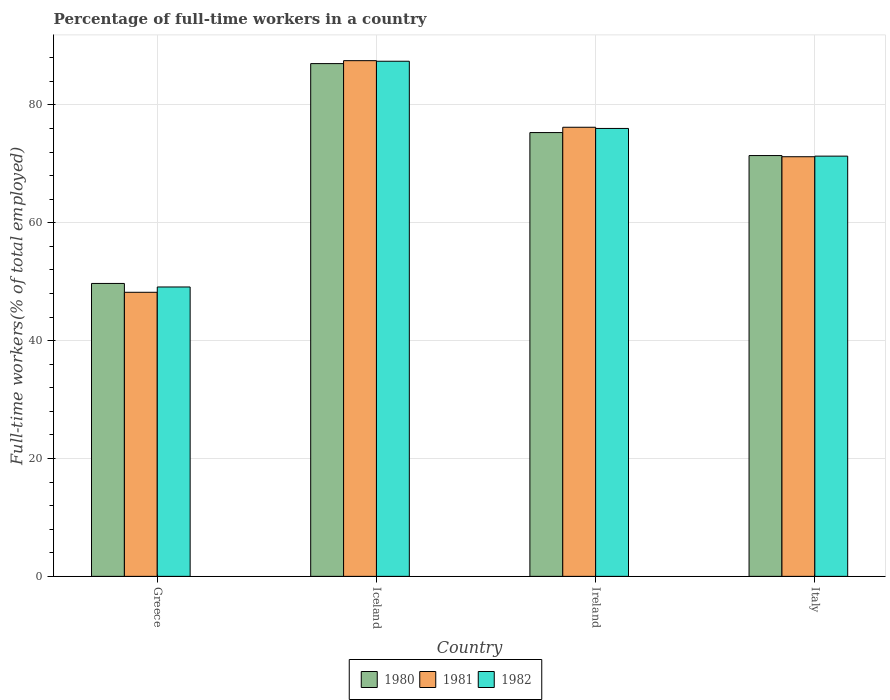Are the number of bars per tick equal to the number of legend labels?
Offer a very short reply. Yes. How many bars are there on the 1st tick from the left?
Keep it short and to the point. 3. How many bars are there on the 4th tick from the right?
Your answer should be compact. 3. What is the percentage of full-time workers in 1981 in Greece?
Make the answer very short. 48.2. Across all countries, what is the maximum percentage of full-time workers in 1981?
Make the answer very short. 87.5. Across all countries, what is the minimum percentage of full-time workers in 1981?
Your response must be concise. 48.2. In which country was the percentage of full-time workers in 1982 maximum?
Your answer should be very brief. Iceland. What is the total percentage of full-time workers in 1981 in the graph?
Your response must be concise. 283.1. What is the difference between the percentage of full-time workers in 1982 in Greece and that in Ireland?
Ensure brevity in your answer.  -26.9. What is the difference between the percentage of full-time workers in 1981 in Ireland and the percentage of full-time workers in 1982 in Iceland?
Give a very brief answer. -11.2. What is the average percentage of full-time workers in 1980 per country?
Keep it short and to the point. 70.85. What is the difference between the percentage of full-time workers of/in 1982 and percentage of full-time workers of/in 1981 in Iceland?
Ensure brevity in your answer.  -0.1. In how many countries, is the percentage of full-time workers in 1982 greater than 36 %?
Provide a short and direct response. 4. What is the ratio of the percentage of full-time workers in 1981 in Ireland to that in Italy?
Keep it short and to the point. 1.07. Is the percentage of full-time workers in 1980 in Greece less than that in Iceland?
Your response must be concise. Yes. Is the difference between the percentage of full-time workers in 1982 in Greece and Iceland greater than the difference between the percentage of full-time workers in 1981 in Greece and Iceland?
Provide a short and direct response. Yes. What is the difference between the highest and the second highest percentage of full-time workers in 1980?
Give a very brief answer. 3.9. What is the difference between the highest and the lowest percentage of full-time workers in 1980?
Your response must be concise. 37.3. Is the sum of the percentage of full-time workers in 1981 in Greece and Italy greater than the maximum percentage of full-time workers in 1980 across all countries?
Offer a terse response. Yes. Is it the case that in every country, the sum of the percentage of full-time workers in 1980 and percentage of full-time workers in 1981 is greater than the percentage of full-time workers in 1982?
Give a very brief answer. Yes. Are all the bars in the graph horizontal?
Your answer should be very brief. No. Does the graph contain any zero values?
Your answer should be very brief. No. Where does the legend appear in the graph?
Provide a succinct answer. Bottom center. How are the legend labels stacked?
Provide a succinct answer. Horizontal. What is the title of the graph?
Offer a very short reply. Percentage of full-time workers in a country. What is the label or title of the X-axis?
Ensure brevity in your answer.  Country. What is the label or title of the Y-axis?
Ensure brevity in your answer.  Full-time workers(% of total employed). What is the Full-time workers(% of total employed) in 1980 in Greece?
Give a very brief answer. 49.7. What is the Full-time workers(% of total employed) of 1981 in Greece?
Your answer should be compact. 48.2. What is the Full-time workers(% of total employed) of 1982 in Greece?
Give a very brief answer. 49.1. What is the Full-time workers(% of total employed) in 1981 in Iceland?
Provide a short and direct response. 87.5. What is the Full-time workers(% of total employed) in 1982 in Iceland?
Offer a terse response. 87.4. What is the Full-time workers(% of total employed) of 1980 in Ireland?
Your answer should be very brief. 75.3. What is the Full-time workers(% of total employed) in 1981 in Ireland?
Make the answer very short. 76.2. What is the Full-time workers(% of total employed) of 1982 in Ireland?
Ensure brevity in your answer.  76. What is the Full-time workers(% of total employed) in 1980 in Italy?
Provide a succinct answer. 71.4. What is the Full-time workers(% of total employed) of 1981 in Italy?
Your answer should be compact. 71.2. What is the Full-time workers(% of total employed) of 1982 in Italy?
Keep it short and to the point. 71.3. Across all countries, what is the maximum Full-time workers(% of total employed) of 1980?
Keep it short and to the point. 87. Across all countries, what is the maximum Full-time workers(% of total employed) of 1981?
Offer a terse response. 87.5. Across all countries, what is the maximum Full-time workers(% of total employed) in 1982?
Keep it short and to the point. 87.4. Across all countries, what is the minimum Full-time workers(% of total employed) in 1980?
Give a very brief answer. 49.7. Across all countries, what is the minimum Full-time workers(% of total employed) of 1981?
Ensure brevity in your answer.  48.2. Across all countries, what is the minimum Full-time workers(% of total employed) in 1982?
Keep it short and to the point. 49.1. What is the total Full-time workers(% of total employed) of 1980 in the graph?
Offer a very short reply. 283.4. What is the total Full-time workers(% of total employed) of 1981 in the graph?
Provide a short and direct response. 283.1. What is the total Full-time workers(% of total employed) of 1982 in the graph?
Give a very brief answer. 283.8. What is the difference between the Full-time workers(% of total employed) of 1980 in Greece and that in Iceland?
Offer a very short reply. -37.3. What is the difference between the Full-time workers(% of total employed) of 1981 in Greece and that in Iceland?
Your answer should be compact. -39.3. What is the difference between the Full-time workers(% of total employed) in 1982 in Greece and that in Iceland?
Offer a very short reply. -38.3. What is the difference between the Full-time workers(% of total employed) in 1980 in Greece and that in Ireland?
Make the answer very short. -25.6. What is the difference between the Full-time workers(% of total employed) in 1981 in Greece and that in Ireland?
Your response must be concise. -28. What is the difference between the Full-time workers(% of total employed) in 1982 in Greece and that in Ireland?
Your response must be concise. -26.9. What is the difference between the Full-time workers(% of total employed) of 1980 in Greece and that in Italy?
Your answer should be very brief. -21.7. What is the difference between the Full-time workers(% of total employed) in 1982 in Greece and that in Italy?
Offer a terse response. -22.2. What is the difference between the Full-time workers(% of total employed) in 1980 in Iceland and that in Ireland?
Provide a short and direct response. 11.7. What is the difference between the Full-time workers(% of total employed) of 1980 in Iceland and that in Italy?
Ensure brevity in your answer.  15.6. What is the difference between the Full-time workers(% of total employed) in 1981 in Iceland and that in Italy?
Ensure brevity in your answer.  16.3. What is the difference between the Full-time workers(% of total employed) of 1982 in Iceland and that in Italy?
Provide a succinct answer. 16.1. What is the difference between the Full-time workers(% of total employed) of 1980 in Ireland and that in Italy?
Your response must be concise. 3.9. What is the difference between the Full-time workers(% of total employed) in 1981 in Ireland and that in Italy?
Offer a terse response. 5. What is the difference between the Full-time workers(% of total employed) of 1982 in Ireland and that in Italy?
Offer a very short reply. 4.7. What is the difference between the Full-time workers(% of total employed) in 1980 in Greece and the Full-time workers(% of total employed) in 1981 in Iceland?
Your answer should be very brief. -37.8. What is the difference between the Full-time workers(% of total employed) of 1980 in Greece and the Full-time workers(% of total employed) of 1982 in Iceland?
Your answer should be compact. -37.7. What is the difference between the Full-time workers(% of total employed) of 1981 in Greece and the Full-time workers(% of total employed) of 1982 in Iceland?
Make the answer very short. -39.2. What is the difference between the Full-time workers(% of total employed) in 1980 in Greece and the Full-time workers(% of total employed) in 1981 in Ireland?
Your answer should be compact. -26.5. What is the difference between the Full-time workers(% of total employed) in 1980 in Greece and the Full-time workers(% of total employed) in 1982 in Ireland?
Give a very brief answer. -26.3. What is the difference between the Full-time workers(% of total employed) of 1981 in Greece and the Full-time workers(% of total employed) of 1982 in Ireland?
Provide a short and direct response. -27.8. What is the difference between the Full-time workers(% of total employed) in 1980 in Greece and the Full-time workers(% of total employed) in 1981 in Italy?
Your response must be concise. -21.5. What is the difference between the Full-time workers(% of total employed) of 1980 in Greece and the Full-time workers(% of total employed) of 1982 in Italy?
Offer a very short reply. -21.6. What is the difference between the Full-time workers(% of total employed) of 1981 in Greece and the Full-time workers(% of total employed) of 1982 in Italy?
Your answer should be very brief. -23.1. What is the difference between the Full-time workers(% of total employed) in 1981 in Iceland and the Full-time workers(% of total employed) in 1982 in Ireland?
Give a very brief answer. 11.5. What is the difference between the Full-time workers(% of total employed) of 1980 in Iceland and the Full-time workers(% of total employed) of 1981 in Italy?
Provide a short and direct response. 15.8. What is the difference between the Full-time workers(% of total employed) in 1980 in Iceland and the Full-time workers(% of total employed) in 1982 in Italy?
Provide a short and direct response. 15.7. What is the difference between the Full-time workers(% of total employed) in 1980 in Ireland and the Full-time workers(% of total employed) in 1982 in Italy?
Make the answer very short. 4. What is the difference between the Full-time workers(% of total employed) of 1981 in Ireland and the Full-time workers(% of total employed) of 1982 in Italy?
Keep it short and to the point. 4.9. What is the average Full-time workers(% of total employed) of 1980 per country?
Make the answer very short. 70.85. What is the average Full-time workers(% of total employed) in 1981 per country?
Make the answer very short. 70.78. What is the average Full-time workers(% of total employed) of 1982 per country?
Offer a very short reply. 70.95. What is the difference between the Full-time workers(% of total employed) in 1980 and Full-time workers(% of total employed) in 1981 in Greece?
Provide a succinct answer. 1.5. What is the difference between the Full-time workers(% of total employed) of 1980 and Full-time workers(% of total employed) of 1982 in Greece?
Offer a terse response. 0.6. What is the difference between the Full-time workers(% of total employed) in 1980 and Full-time workers(% of total employed) in 1981 in Iceland?
Provide a succinct answer. -0.5. What is the difference between the Full-time workers(% of total employed) in 1980 and Full-time workers(% of total employed) in 1982 in Iceland?
Keep it short and to the point. -0.4. What is the difference between the Full-time workers(% of total employed) in 1981 and Full-time workers(% of total employed) in 1982 in Iceland?
Make the answer very short. 0.1. What is the difference between the Full-time workers(% of total employed) of 1980 and Full-time workers(% of total employed) of 1982 in Ireland?
Provide a short and direct response. -0.7. What is the difference between the Full-time workers(% of total employed) of 1981 and Full-time workers(% of total employed) of 1982 in Ireland?
Your answer should be compact. 0.2. What is the difference between the Full-time workers(% of total employed) of 1980 and Full-time workers(% of total employed) of 1981 in Italy?
Offer a terse response. 0.2. What is the difference between the Full-time workers(% of total employed) of 1980 and Full-time workers(% of total employed) of 1982 in Italy?
Provide a succinct answer. 0.1. What is the ratio of the Full-time workers(% of total employed) of 1980 in Greece to that in Iceland?
Offer a terse response. 0.57. What is the ratio of the Full-time workers(% of total employed) in 1981 in Greece to that in Iceland?
Your answer should be compact. 0.55. What is the ratio of the Full-time workers(% of total employed) in 1982 in Greece to that in Iceland?
Make the answer very short. 0.56. What is the ratio of the Full-time workers(% of total employed) of 1980 in Greece to that in Ireland?
Give a very brief answer. 0.66. What is the ratio of the Full-time workers(% of total employed) of 1981 in Greece to that in Ireland?
Offer a terse response. 0.63. What is the ratio of the Full-time workers(% of total employed) in 1982 in Greece to that in Ireland?
Provide a short and direct response. 0.65. What is the ratio of the Full-time workers(% of total employed) in 1980 in Greece to that in Italy?
Your answer should be very brief. 0.7. What is the ratio of the Full-time workers(% of total employed) of 1981 in Greece to that in Italy?
Provide a succinct answer. 0.68. What is the ratio of the Full-time workers(% of total employed) in 1982 in Greece to that in Italy?
Your answer should be very brief. 0.69. What is the ratio of the Full-time workers(% of total employed) in 1980 in Iceland to that in Ireland?
Keep it short and to the point. 1.16. What is the ratio of the Full-time workers(% of total employed) in 1981 in Iceland to that in Ireland?
Offer a terse response. 1.15. What is the ratio of the Full-time workers(% of total employed) of 1982 in Iceland to that in Ireland?
Your answer should be compact. 1.15. What is the ratio of the Full-time workers(% of total employed) of 1980 in Iceland to that in Italy?
Give a very brief answer. 1.22. What is the ratio of the Full-time workers(% of total employed) of 1981 in Iceland to that in Italy?
Give a very brief answer. 1.23. What is the ratio of the Full-time workers(% of total employed) in 1982 in Iceland to that in Italy?
Make the answer very short. 1.23. What is the ratio of the Full-time workers(% of total employed) of 1980 in Ireland to that in Italy?
Make the answer very short. 1.05. What is the ratio of the Full-time workers(% of total employed) in 1981 in Ireland to that in Italy?
Ensure brevity in your answer.  1.07. What is the ratio of the Full-time workers(% of total employed) of 1982 in Ireland to that in Italy?
Offer a very short reply. 1.07. What is the difference between the highest and the second highest Full-time workers(% of total employed) in 1982?
Your answer should be compact. 11.4. What is the difference between the highest and the lowest Full-time workers(% of total employed) in 1980?
Your answer should be very brief. 37.3. What is the difference between the highest and the lowest Full-time workers(% of total employed) of 1981?
Your answer should be very brief. 39.3. What is the difference between the highest and the lowest Full-time workers(% of total employed) of 1982?
Provide a short and direct response. 38.3. 